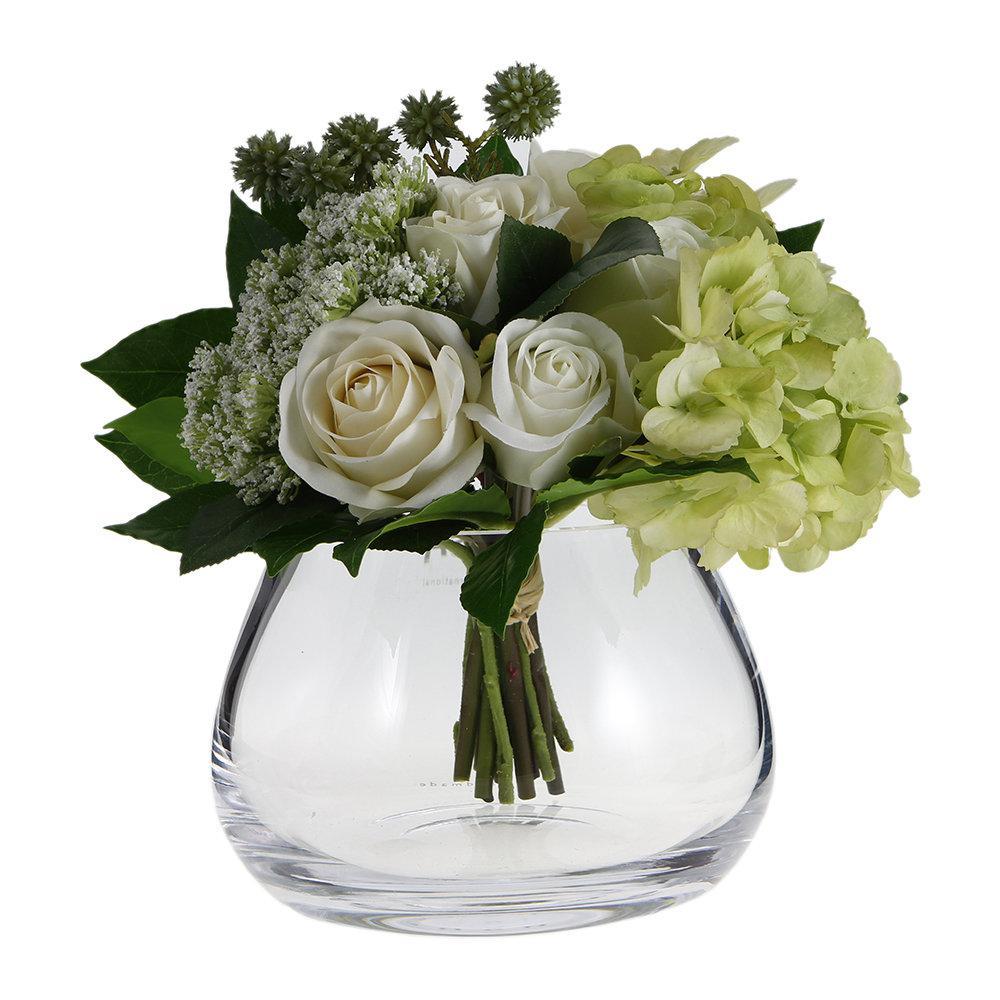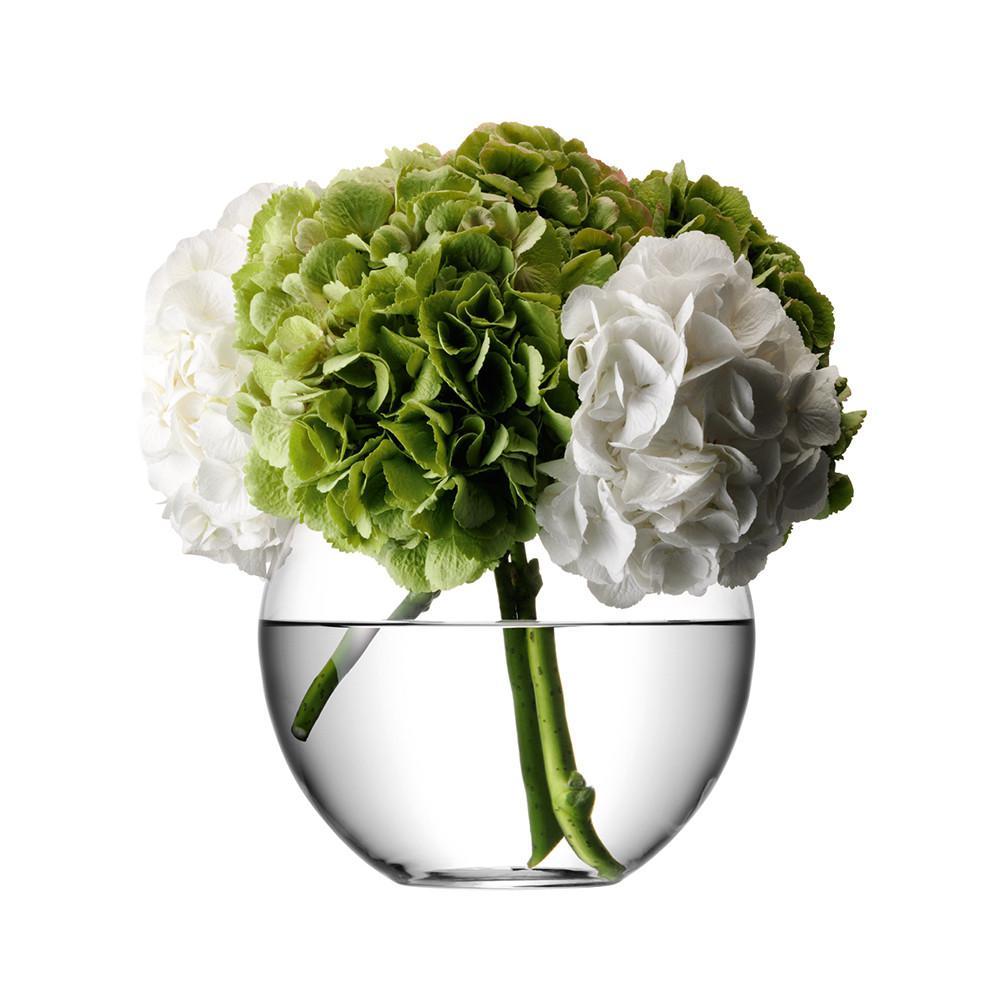The first image is the image on the left, the second image is the image on the right. Considering the images on both sides, is "There are two round, clear vases with flowers in them" valid? Answer yes or no. Yes. The first image is the image on the left, the second image is the image on the right. Considering the images on both sides, is "there are pink flowers in a vase" valid? Answer yes or no. No. 